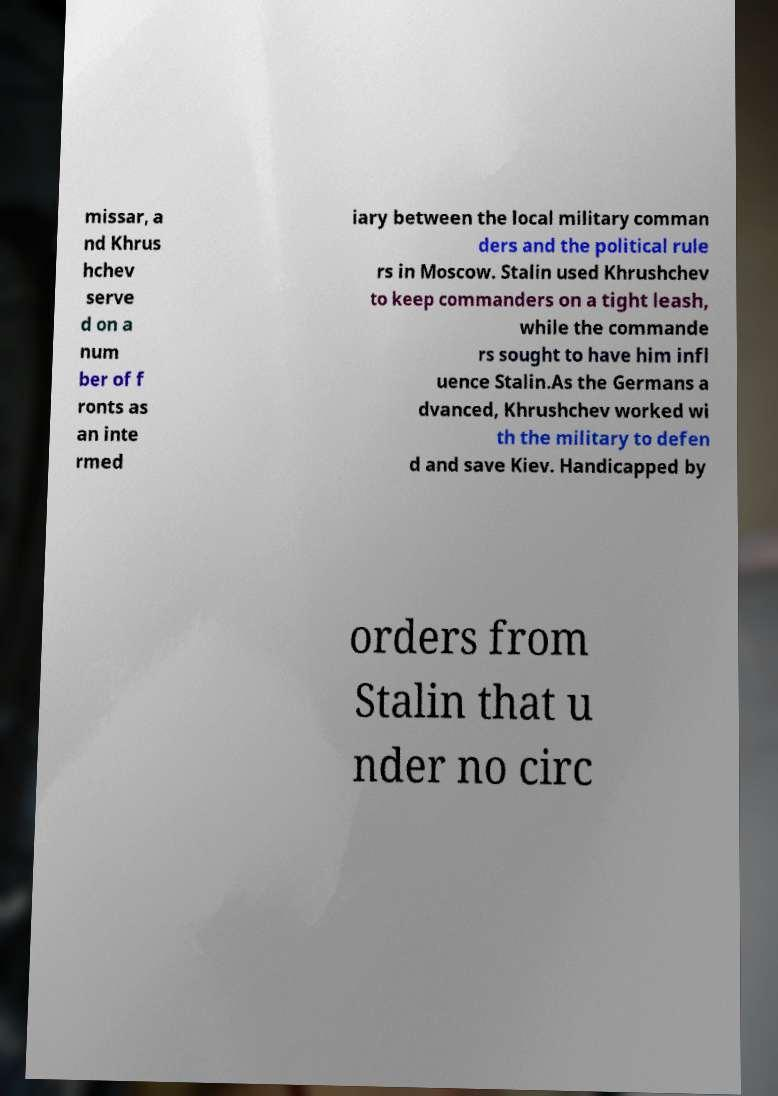Could you assist in decoding the text presented in this image and type it out clearly? missar, a nd Khrus hchev serve d on a num ber of f ronts as an inte rmed iary between the local military comman ders and the political rule rs in Moscow. Stalin used Khrushchev to keep commanders on a tight leash, while the commande rs sought to have him infl uence Stalin.As the Germans a dvanced, Khrushchev worked wi th the military to defen d and save Kiev. Handicapped by orders from Stalin that u nder no circ 